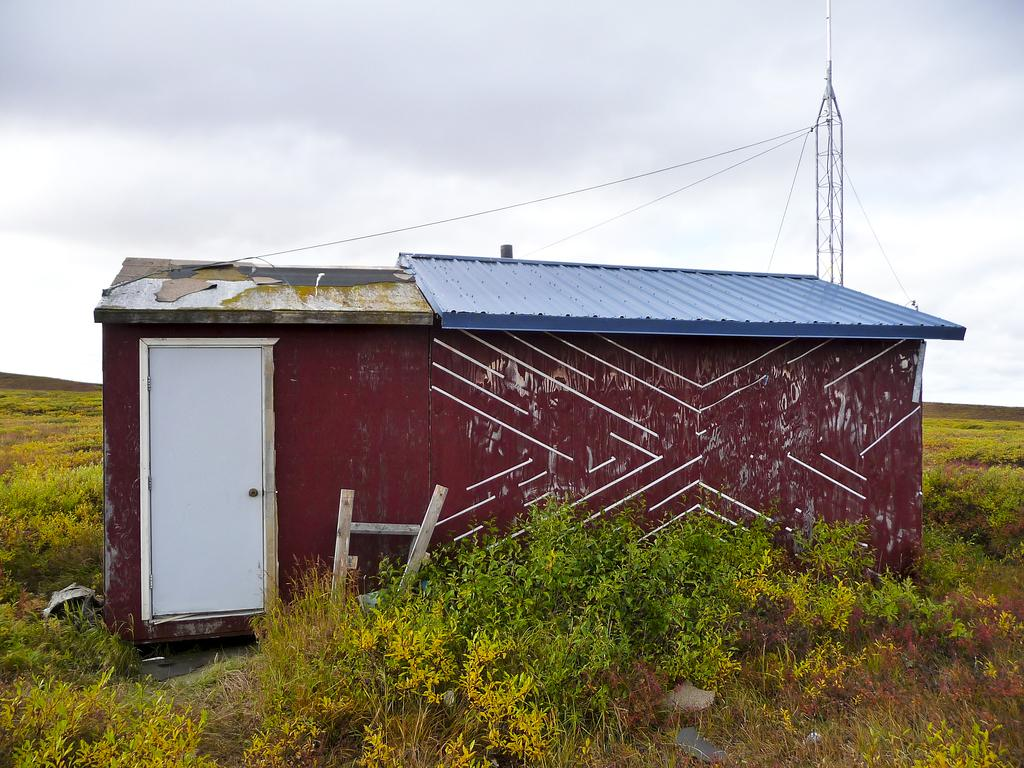What type of structure is visible in the image? There is a house in the image. What other objects can be seen in the image? There are plants, a tower, and wires visible in the image. What is visible in the background of the image? The sky is visible in the background of the image. What type of treatment is being administered to the plants in the image? There is no indication of any treatment being administered to the plants in the image. 